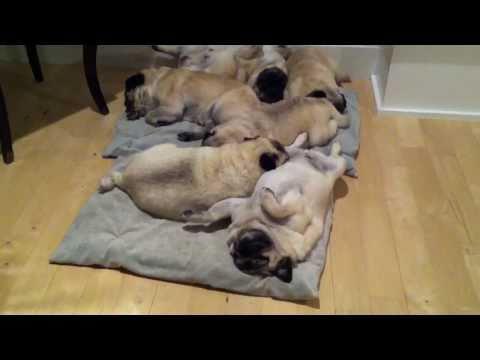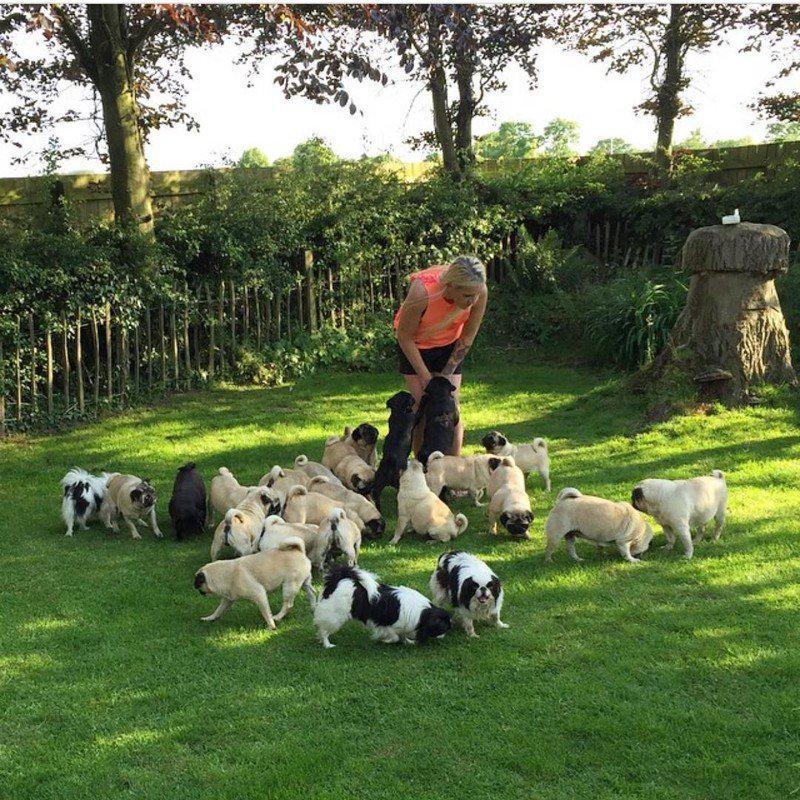The first image is the image on the left, the second image is the image on the right. Assess this claim about the two images: "In one image, a woman is shown with many little dogs.". Correct or not? Answer yes or no. Yes. The first image is the image on the left, the second image is the image on the right. For the images displayed, is the sentence "There is a person in the image on the right." factually correct? Answer yes or no. Yes. 